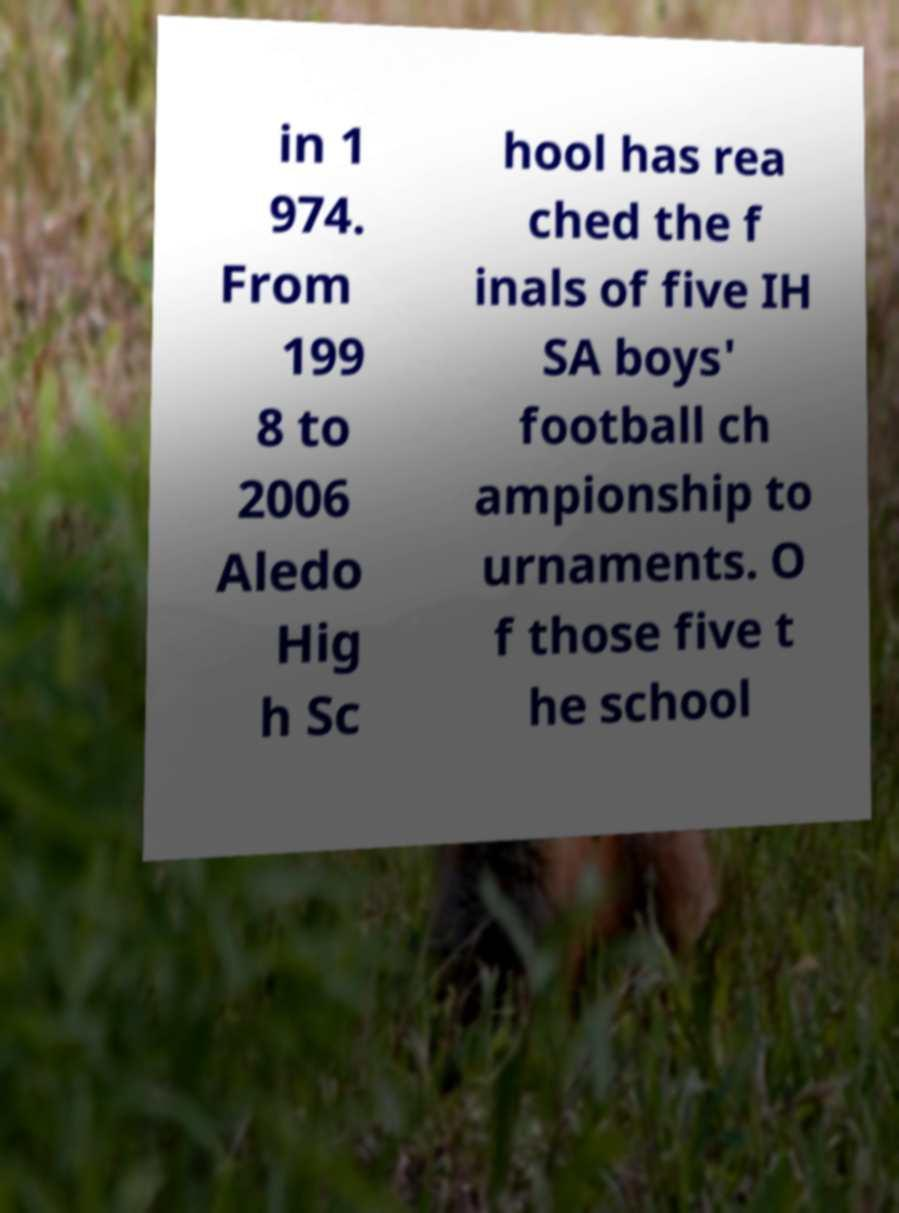There's text embedded in this image that I need extracted. Can you transcribe it verbatim? in 1 974. From 199 8 to 2006 Aledo Hig h Sc hool has rea ched the f inals of five IH SA boys' football ch ampionship to urnaments. O f those five t he school 